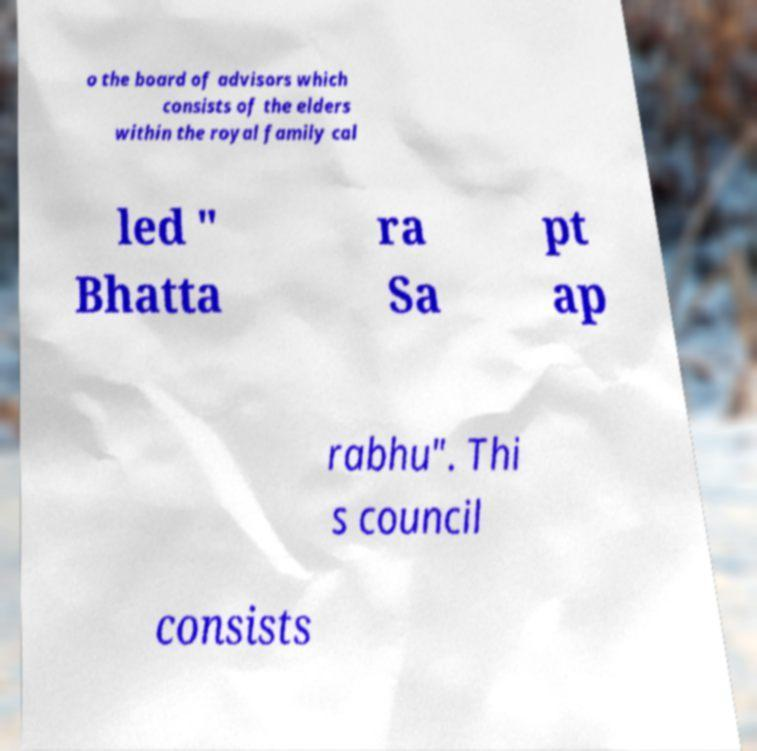Can you read and provide the text displayed in the image?This photo seems to have some interesting text. Can you extract and type it out for me? o the board of advisors which consists of the elders within the royal family cal led " Bhatta ra Sa pt ap rabhu". Thi s council consists 